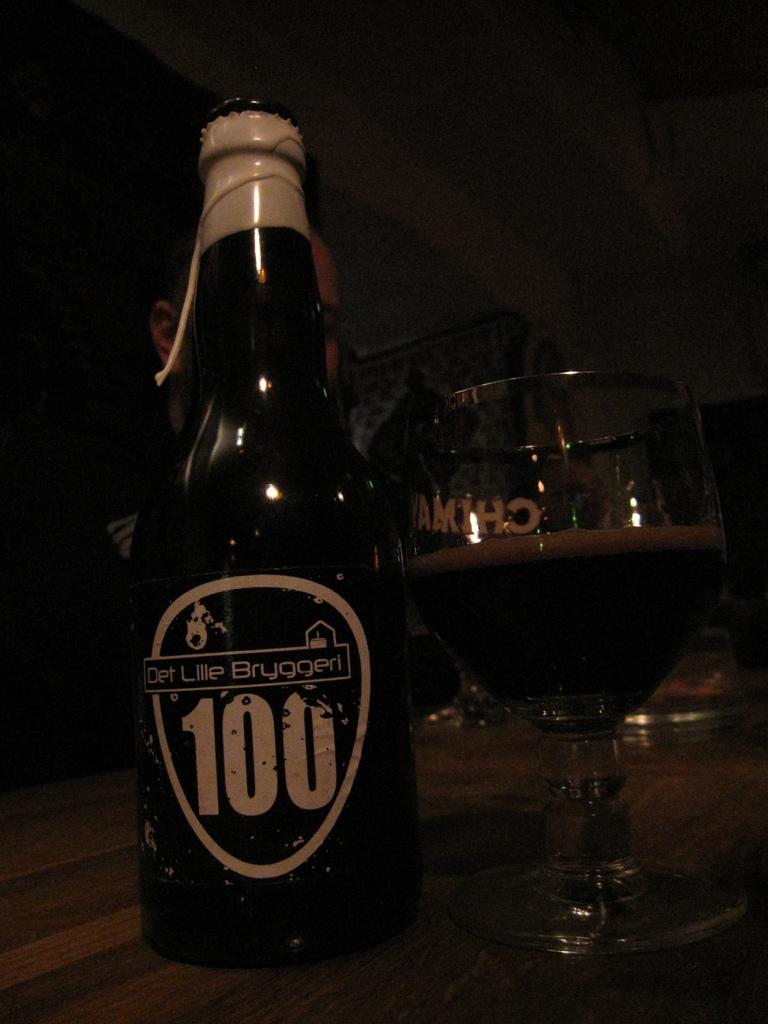<image>
Provide a brief description of the given image. A bottle of Det Lille Bryggeri 100 sits next to a half full glass. 